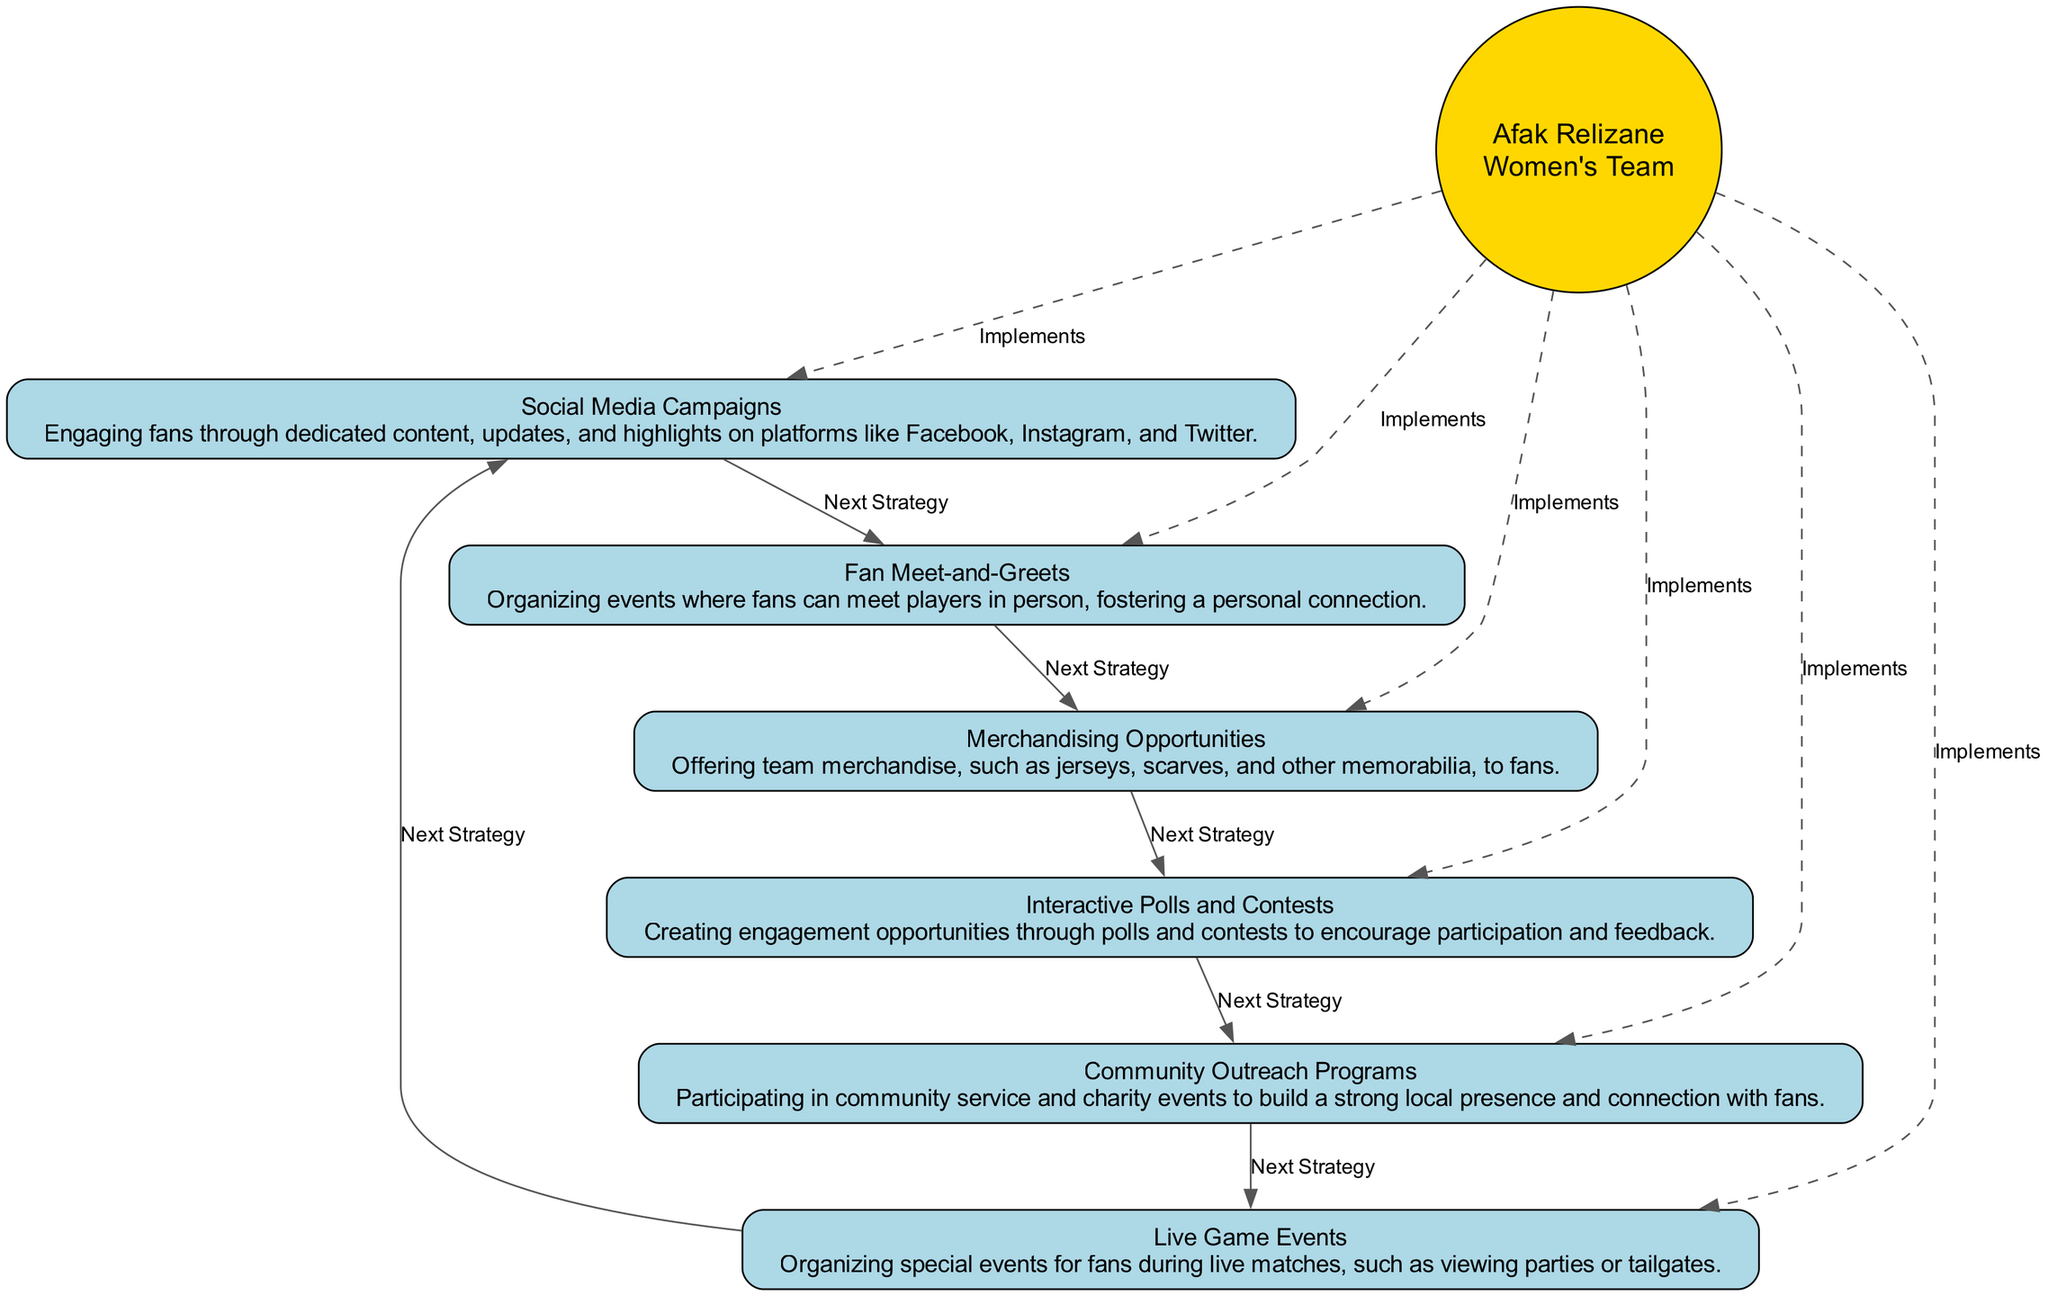What is the total number of engagement strategies depicted in the chart? The diagram lists six distinct strategies, which can be counted directly from the nodes. Each strategy is represented as a separate block in the flow chart.
Answer: 6 What is the first engagement strategy listed in the diagram? The first strategy per the arrangement is "Social Media Campaigns," which is located at the top of the flow chart.
Answer: Social Media Campaigns Which strategy focuses on organizing events for fans to meet players? The strategy that explicitly mentions organizing meet-and-greet events for fans to meet players is "Fan Meet-and-Greets." It's indicated as a dedicated engagement within the flow.
Answer: Fan Meet-and-Greets How many edges connect the central node to the engagement strategies? The central node "Afak Relizane Women’s Team" connects to all six engagement strategies, resulting in six distinct dashed edges linking them.
Answer: 6 Which engagement strategy corresponds to offering team merchandise? The strategy that addresses offering team merchandise, like jerseys and other items, is "Merchandising Opportunities." This is clearly labeled in the diagram.
Answer: Merchandising Opportunities What is the last engagement strategy in the circular arrangement? The last strategy in the circular flow of strategies is "Live Game Events." This can be deduced by following the circular connections back around to the initial strategies.
Answer: Live Game Events Which strategy might involve local community service events? The strategy that suggests involvement in community service and charity events is "Community Outreach Programs." This is explicitly mentioned in the description.
Answer: Community Outreach Programs Which engagement strategy encourages fan participation through contests? The strategy designed to engage fans through participation and feedback via contests is "Interactive Polls and Contests," as highlighted in the flow.
Answer: Interactive Polls and Contests What style connects the central node to all other strategies? The style used to connect the central node to all strategies is dashed, which is specified for those connecting lines in the diagram.
Answer: Dashed 